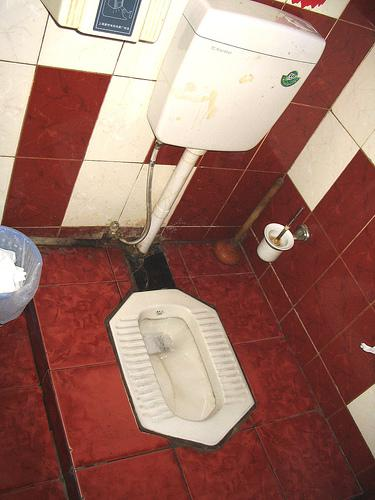Question: what are the colors of the tiles?
Choices:
A. Black and white.
B. White and red.
C. Green.
D. Blue.
Answer with the letter. Answer: B Question: where is the trash can?
Choices:
A. On the right.
B. On the left.
C. On the stairs.
D. Under the sink.
Answer with the letter. Answer: B Question: where is this photo taken?
Choices:
A. Bedroom.
B. A bathroom.
C. Kitchen.
D. Closet.
Answer with the letter. Answer: B 